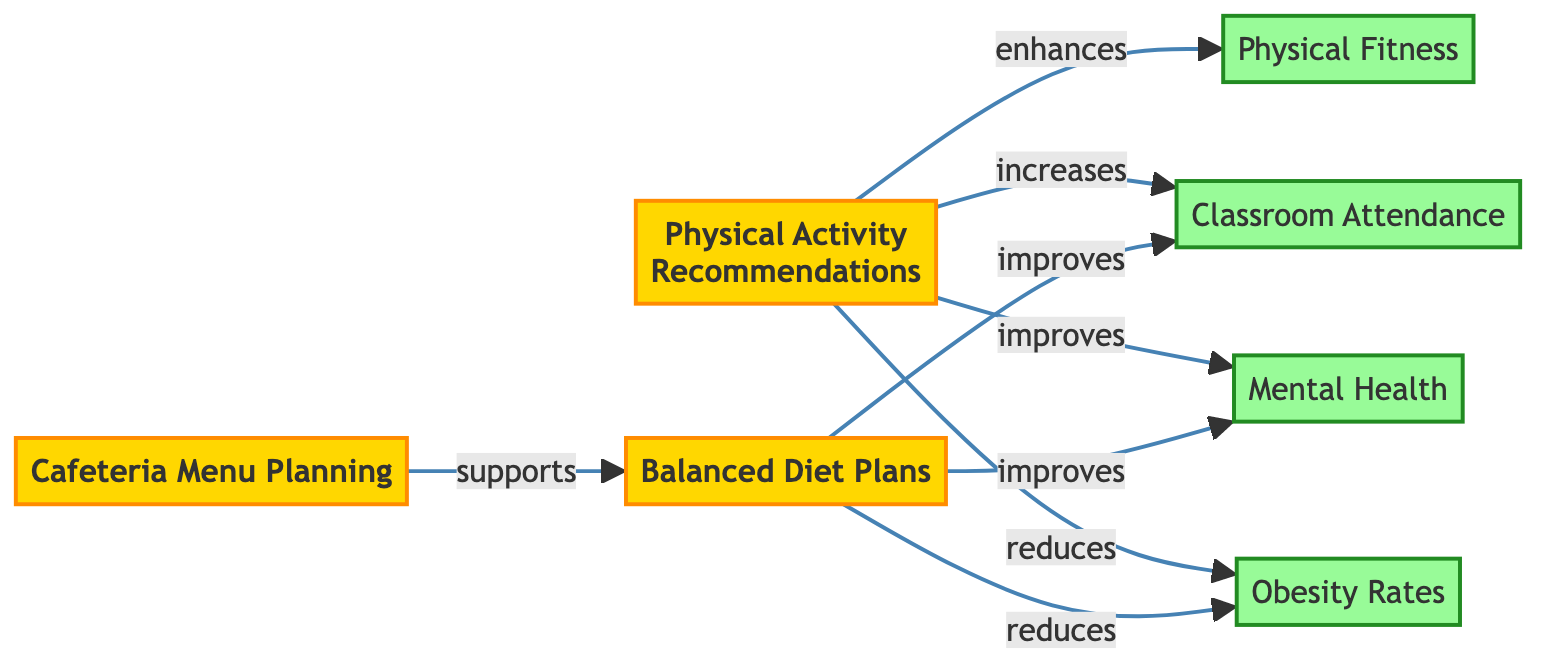What are the initiatives represented in the diagram? The diagram shows three initiatives: Physical Activity Recommendations, Balanced Diet Plans, and Cafeteria Menu Planning.
Answer: Physical Activity Recommendations, Balanced Diet Plans, Cafeteria Menu Planning How many outcomes are identified in the network? There are four outcomes in the diagram: Obesity Rates, Mental Health, Physical Fitness, and Classroom Attendance.
Answer: Four What is the relationship between Physical Activity Recommendations and Obesity Rates? The diagram shows that Physical Activity Recommendations reduce Obesity Rates as indicated by the arrow labeled "reduces."
Answer: Reduces Which initiative supports Balanced Diet Plans? The connection from Cafeteria Menu Planning to Balanced Diet Plans labeled "supports" indicates that Cafeteria Menu Planning supports this initiative.
Answer: Cafeteria Menu Planning Which outcome is enhanced by Physical Activity Recommendations? The diagram states that Physical Activity Recommendations are linked to Physical Fitness with the label "enhances," indicating a positive impact.
Answer: Physical Fitness What are the influences of Balanced Diet Plans on health outcomes? Balanced Diet Plans reduce Obesity Rates and improve both Mental Health and Classroom Attendance as represented by the arrows from Balanced Diet Plans to these outcomes.
Answer: Reduces Obesity Rates, Improves Mental Health, Improves Classroom Attendance Which outcome is increased by Physical Activity Recommendations that is not directly related to health? The diagram indicates that Physical Activity Recommendations increase Classroom Attendance, which is an outcome not directly related to health.
Answer: Classroom Attendance How many edges connect the initiatives to the outcomes in total? Counting all the edges, three connect from Physical Activity Recommendations and three connect from Balanced Diet Plans, making a total of six.
Answer: Six What type of relationship do Balanced Diet Plans have with Classroom Attendance? The relationship shown in the diagram indicates that Balanced Diet Plans improve Classroom Attendance, which is labeled "improves."
Answer: Improves 